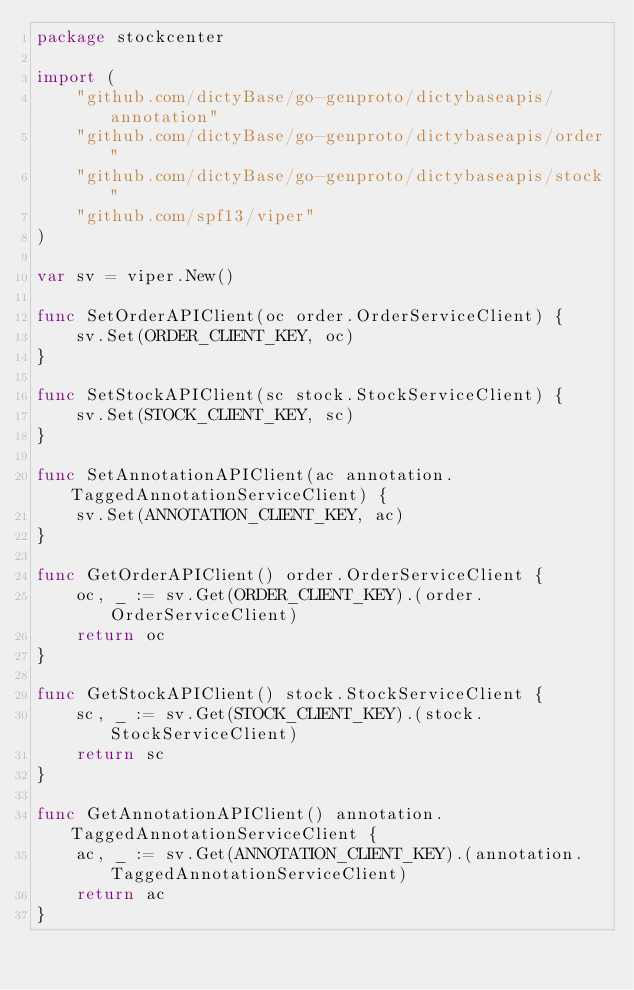Convert code to text. <code><loc_0><loc_0><loc_500><loc_500><_Go_>package stockcenter

import (
	"github.com/dictyBase/go-genproto/dictybaseapis/annotation"
	"github.com/dictyBase/go-genproto/dictybaseapis/order"
	"github.com/dictyBase/go-genproto/dictybaseapis/stock"
	"github.com/spf13/viper"
)

var sv = viper.New()

func SetOrderAPIClient(oc order.OrderServiceClient) {
	sv.Set(ORDER_CLIENT_KEY, oc)
}

func SetStockAPIClient(sc stock.StockServiceClient) {
	sv.Set(STOCK_CLIENT_KEY, sc)
}

func SetAnnotationAPIClient(ac annotation.TaggedAnnotationServiceClient) {
	sv.Set(ANNOTATION_CLIENT_KEY, ac)
}

func GetOrderAPIClient() order.OrderServiceClient {
	oc, _ := sv.Get(ORDER_CLIENT_KEY).(order.OrderServiceClient)
	return oc
}

func GetStockAPIClient() stock.StockServiceClient {
	sc, _ := sv.Get(STOCK_CLIENT_KEY).(stock.StockServiceClient)
	return sc
}

func GetAnnotationAPIClient() annotation.TaggedAnnotationServiceClient {
	ac, _ := sv.Get(ANNOTATION_CLIENT_KEY).(annotation.TaggedAnnotationServiceClient)
	return ac
}
</code> 